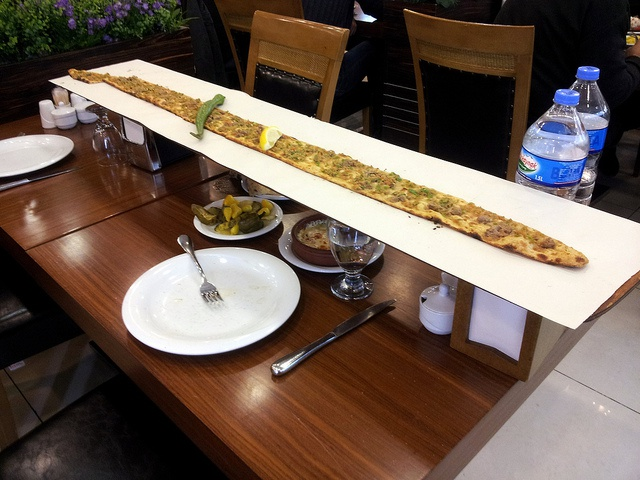Describe the objects in this image and their specific colors. I can see dining table in black, maroon, and lightgray tones, pizza in black, tan, and olive tones, dining table in black, maroon, and brown tones, people in black, brown, maroon, and gray tones, and chair in black, maroon, and brown tones in this image. 